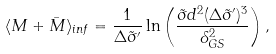<formula> <loc_0><loc_0><loc_500><loc_500>\langle M + \bar { M } \rangle _ { i n f } = \frac { 1 } { \Delta \tilde { \sigma } ^ { \prime } } \ln \left ( \frac { \tilde { \sigma } d ^ { 2 } ( \Delta \tilde { \sigma } ^ { \prime } ) ^ { 3 } } { \delta _ { G S } ^ { 2 } } \right ) ,</formula> 